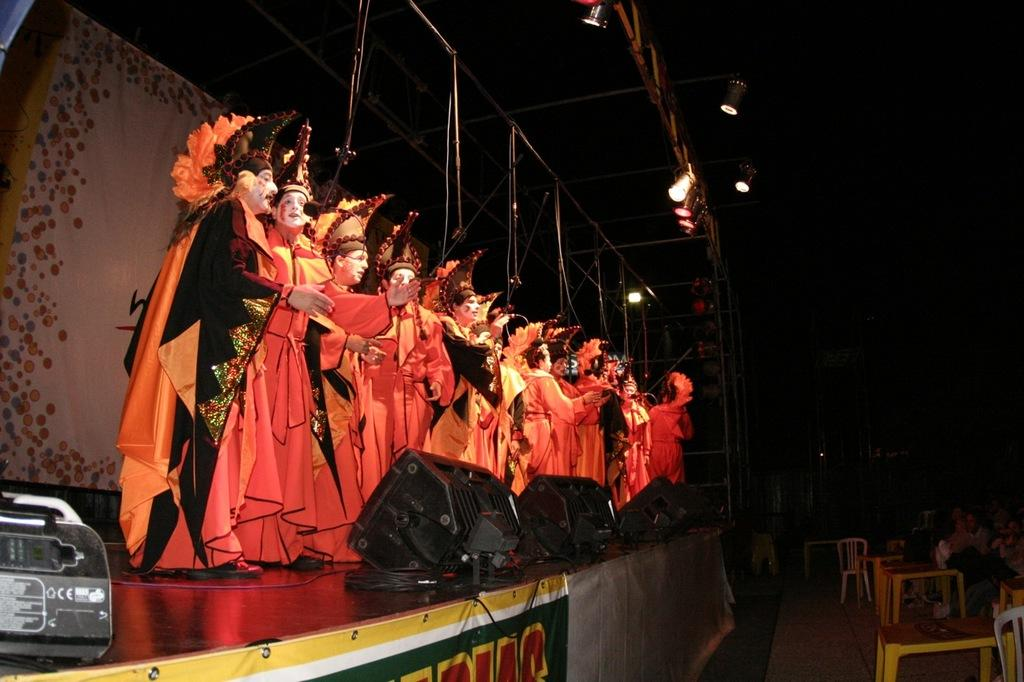What can be seen at the top of the image? There are lights visible at the top of the image. What are the people in the image doing? The people are performing in fancy dress on a platform. What objects are present in the image besides the people and platform? There are devices present in the image. What type of seating is available near the platform? Chairs are near the platform. Can you tell me how many streams are flowing through the image? There are no streams present in the image; it features lights, people performing in fancy dress, devices, and chairs near a platform. What type of division can be seen between the people and the audience in the image? There is no visible division between the people performing and the audience in the image; they are all in the same space. 